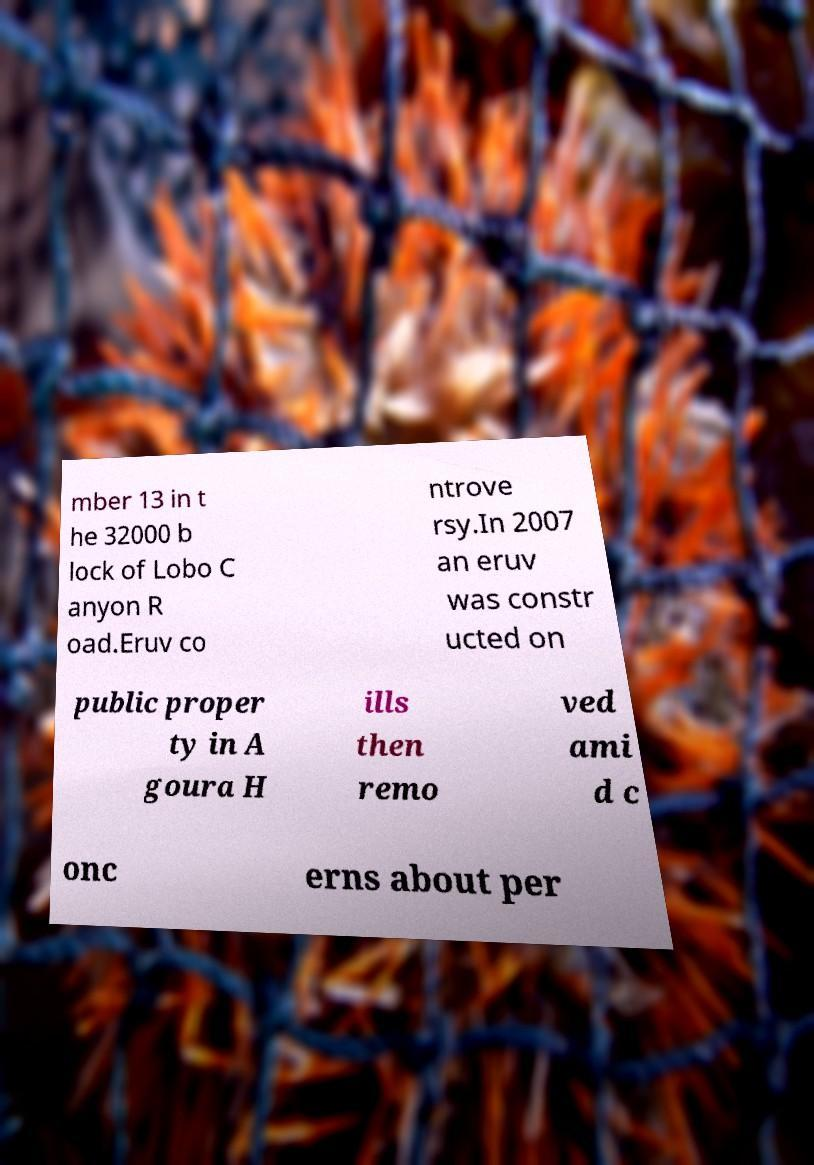Please identify and transcribe the text found in this image. mber 13 in t he 32000 b lock of Lobo C anyon R oad.Eruv co ntrove rsy.In 2007 an eruv was constr ucted on public proper ty in A goura H ills then remo ved ami d c onc erns about per 